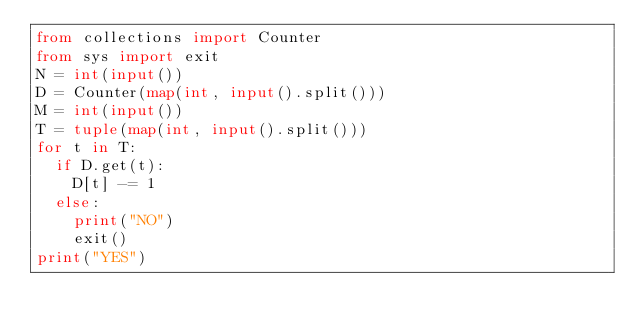Convert code to text. <code><loc_0><loc_0><loc_500><loc_500><_Python_>from collections import Counter
from sys import exit
N = int(input())
D = Counter(map(int, input().split()))
M = int(input())
T = tuple(map(int, input().split()))
for t in T:
  if D.get(t):
    D[t] -= 1
  else:
    print("NO")
    exit()
print("YES")</code> 